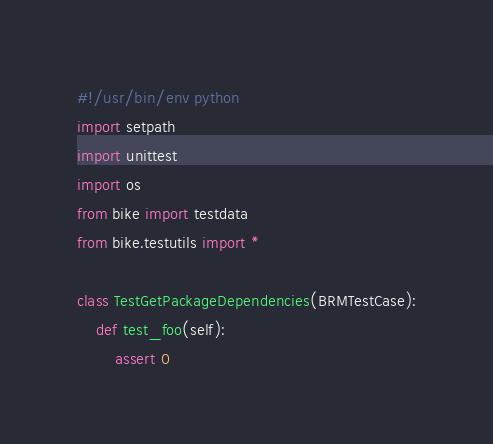<code> <loc_0><loc_0><loc_500><loc_500><_Python_>#!/usr/bin/env python
import setpath
import unittest
import os
from bike import testdata
from bike.testutils import *

class TestGetPackageDependencies(BRMTestCase):
    def test_foo(self):
        assert 0
</code> 